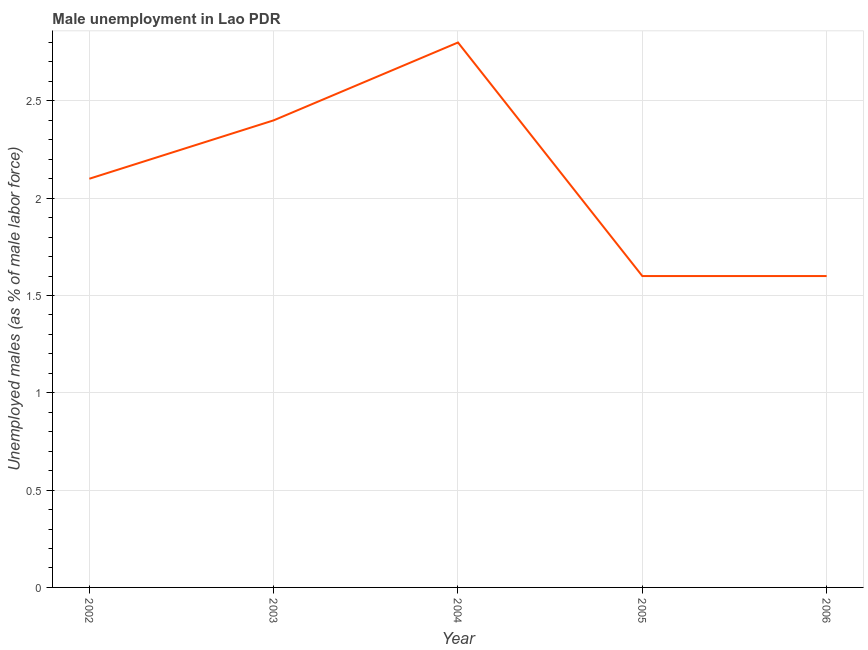What is the unemployed males population in 2004?
Provide a short and direct response. 2.8. Across all years, what is the maximum unemployed males population?
Your response must be concise. 2.8. Across all years, what is the minimum unemployed males population?
Give a very brief answer. 1.6. In which year was the unemployed males population maximum?
Offer a terse response. 2004. In which year was the unemployed males population minimum?
Your response must be concise. 2005. What is the difference between the unemployed males population in 2002 and 2005?
Provide a succinct answer. 0.5. What is the median unemployed males population?
Offer a terse response. 2.1. In how many years, is the unemployed males population greater than 0.30000000000000004 %?
Offer a very short reply. 5. What is the ratio of the unemployed males population in 2002 to that in 2003?
Your answer should be very brief. 0.87. What is the difference between the highest and the second highest unemployed males population?
Make the answer very short. 0.4. Is the sum of the unemployed males population in 2003 and 2004 greater than the maximum unemployed males population across all years?
Ensure brevity in your answer.  Yes. What is the difference between the highest and the lowest unemployed males population?
Your response must be concise. 1.2. Does the unemployed males population monotonically increase over the years?
Ensure brevity in your answer.  No. How many lines are there?
Offer a very short reply. 1. What is the difference between two consecutive major ticks on the Y-axis?
Give a very brief answer. 0.5. Are the values on the major ticks of Y-axis written in scientific E-notation?
Ensure brevity in your answer.  No. Does the graph contain any zero values?
Ensure brevity in your answer.  No. Does the graph contain grids?
Keep it short and to the point. Yes. What is the title of the graph?
Give a very brief answer. Male unemployment in Lao PDR. What is the label or title of the Y-axis?
Give a very brief answer. Unemployed males (as % of male labor force). What is the Unemployed males (as % of male labor force) of 2002?
Keep it short and to the point. 2.1. What is the Unemployed males (as % of male labor force) in 2003?
Your answer should be very brief. 2.4. What is the Unemployed males (as % of male labor force) of 2004?
Your response must be concise. 2.8. What is the Unemployed males (as % of male labor force) in 2005?
Your answer should be very brief. 1.6. What is the Unemployed males (as % of male labor force) of 2006?
Provide a succinct answer. 1.6. What is the difference between the Unemployed males (as % of male labor force) in 2002 and 2003?
Your answer should be compact. -0.3. What is the difference between the Unemployed males (as % of male labor force) in 2002 and 2004?
Ensure brevity in your answer.  -0.7. What is the difference between the Unemployed males (as % of male labor force) in 2002 and 2005?
Ensure brevity in your answer.  0.5. What is the difference between the Unemployed males (as % of male labor force) in 2003 and 2004?
Ensure brevity in your answer.  -0.4. What is the difference between the Unemployed males (as % of male labor force) in 2005 and 2006?
Offer a very short reply. 0. What is the ratio of the Unemployed males (as % of male labor force) in 2002 to that in 2005?
Offer a terse response. 1.31. What is the ratio of the Unemployed males (as % of male labor force) in 2002 to that in 2006?
Offer a very short reply. 1.31. What is the ratio of the Unemployed males (as % of male labor force) in 2003 to that in 2004?
Your answer should be compact. 0.86. What is the ratio of the Unemployed males (as % of male labor force) in 2003 to that in 2005?
Keep it short and to the point. 1.5. What is the ratio of the Unemployed males (as % of male labor force) in 2004 to that in 2006?
Your response must be concise. 1.75. What is the ratio of the Unemployed males (as % of male labor force) in 2005 to that in 2006?
Make the answer very short. 1. 